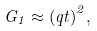<formula> <loc_0><loc_0><loc_500><loc_500>G _ { 1 } \approx { ( q t ) } ^ { 2 } ,</formula> 